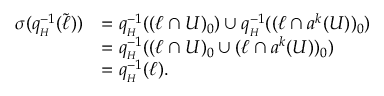<formula> <loc_0><loc_0><loc_500><loc_500>\begin{array} { r l } { \sigma ( q _ { _ { H } } ^ { - 1 } ( \tilde { \ell } ) ) } & { = q _ { _ { H } } ^ { - 1 } ( ( \ell \cap U ) _ { 0 } ) \cup q _ { _ { H } } ^ { - 1 } ( ( \ell \cap a ^ { k } ( U ) ) _ { 0 } ) } \\ & { = q _ { _ { H } } ^ { - 1 } ( ( \ell \cap U ) _ { 0 } \cup ( \ell \cap a ^ { k } ( U ) ) _ { 0 } ) } \\ & { = q _ { _ { H } } ^ { - 1 } ( \ell ) . } \end{array}</formula> 